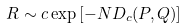<formula> <loc_0><loc_0><loc_500><loc_500>R \sim c \exp \left [ - N D _ { c } ( P , Q ) \right ]</formula> 